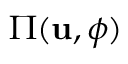Convert formula to latex. <formula><loc_0><loc_0><loc_500><loc_500>\Pi ( u , \phi )</formula> 